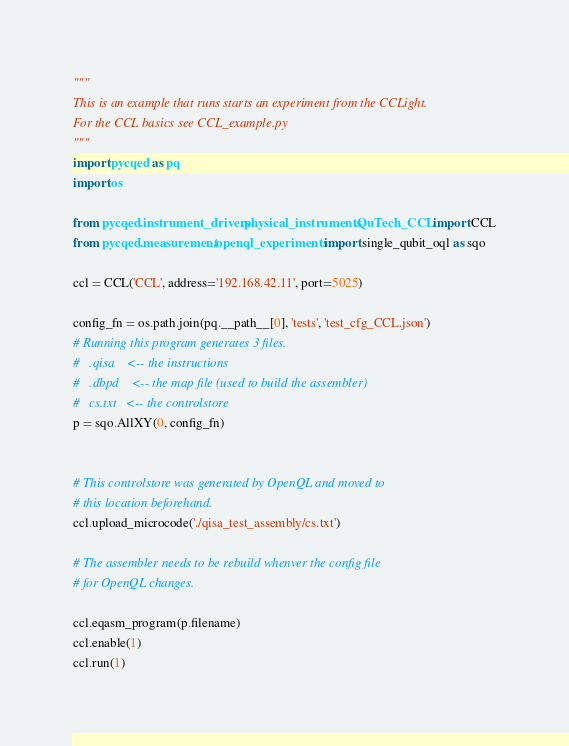<code> <loc_0><loc_0><loc_500><loc_500><_Python_>"""
This is an example that runs starts an experiment from the CCLight.
For the CCL basics see CCL_example.py
"""
import pycqed as pq
import os

from pycqed.instrument_drivers.physical_instruments.QuTech_CCL import CCL
from pycqed.measurement.openql_experiments import single_qubit_oql as sqo

ccl = CCL('CCL', address='192.168.42.11', port=5025)

config_fn = os.path.join(pq.__path__[0], 'tests', 'test_cfg_CCL.json')
# Running this program generates 3 files.
#   .qisa    <-- the instructions
#   .dbpd    <-- the map file (used to build the assembler)
#   cs.txt   <-- the controlstore
p = sqo.AllXY(0, config_fn)


# This controlstore was generated by OpenQL and moved to
# this location beforehand.
ccl.upload_microcode('./qisa_test_assembly/cs.txt')

# The assembler needs to be rebuild whenver the config file
# for OpenQL changes.

ccl.eqasm_program(p.filename)
ccl.enable(1)
ccl.run(1)
</code> 